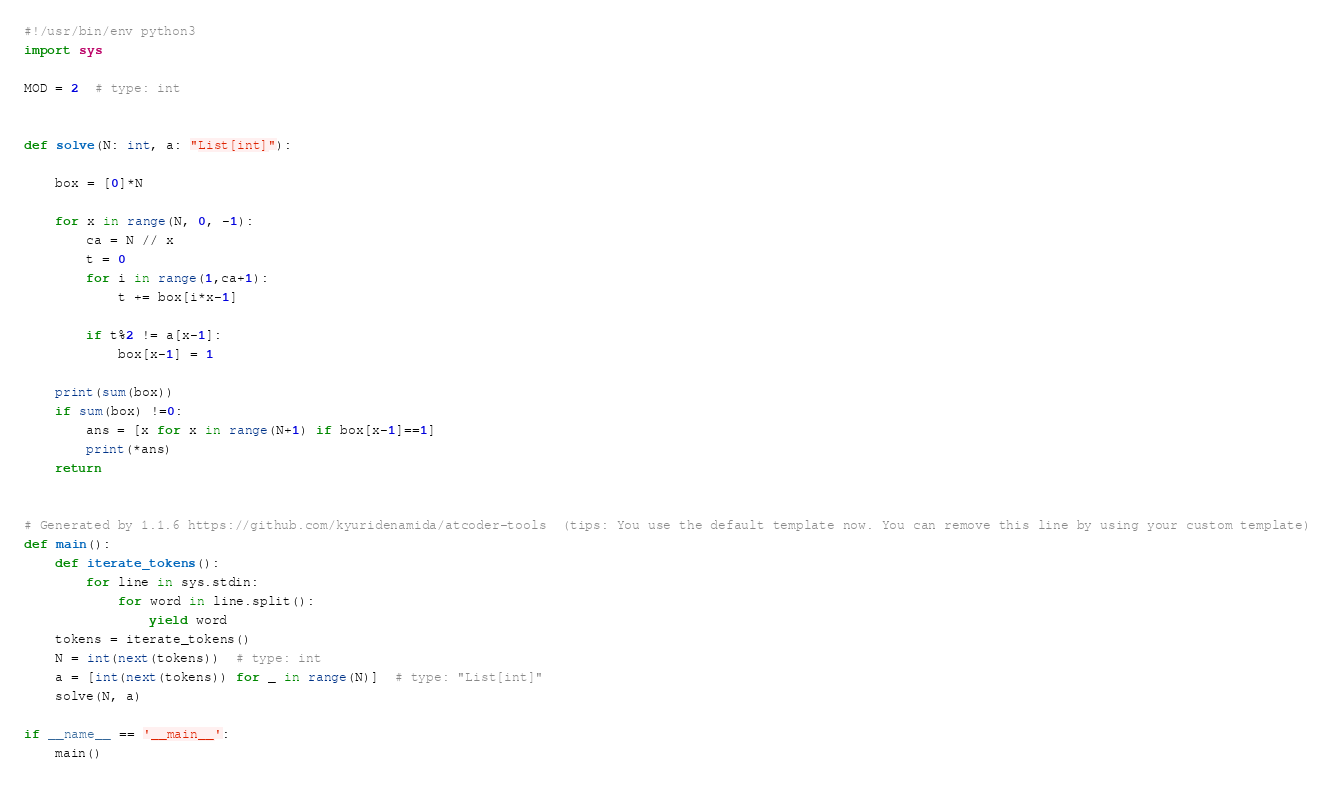<code> <loc_0><loc_0><loc_500><loc_500><_Python_>#!/usr/bin/env python3
import sys

MOD = 2  # type: int


def solve(N: int, a: "List[int]"):

    box = [0]*N

    for x in range(N, 0, -1):
        ca = N // x
        t = 0
        for i in range(1,ca+1):
            t += box[i*x-1]
        
        if t%2 != a[x-1]:
            box[x-1] = 1

    print(sum(box))
    if sum(box) !=0:
        ans = [x for x in range(N+1) if box[x-1]==1]
        print(*ans)
    return


# Generated by 1.1.6 https://github.com/kyuridenamida/atcoder-tools  (tips: You use the default template now. You can remove this line by using your custom template)
def main():
    def iterate_tokens():
        for line in sys.stdin:
            for word in line.split():
                yield word
    tokens = iterate_tokens()
    N = int(next(tokens))  # type: int
    a = [int(next(tokens)) for _ in range(N)]  # type: "List[int]"
    solve(N, a)

if __name__ == '__main__':
    main()
</code> 